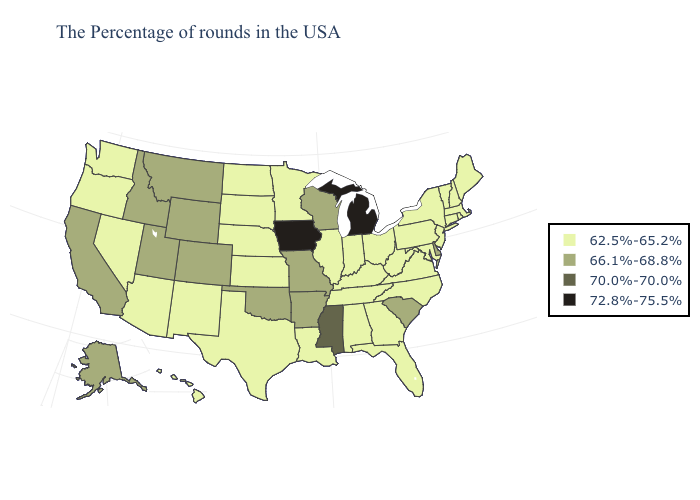Among the states that border Pennsylvania , which have the highest value?
Give a very brief answer. Delaware. Name the states that have a value in the range 70.0%-70.0%?
Quick response, please. Mississippi. Does Delaware have the highest value in the South?
Write a very short answer. No. Does the map have missing data?
Be succinct. No. Name the states that have a value in the range 72.8%-75.5%?
Keep it brief. Michigan, Iowa. What is the value of New Hampshire?
Give a very brief answer. 62.5%-65.2%. What is the highest value in the Northeast ?
Write a very short answer. 62.5%-65.2%. What is the value of New Jersey?
Give a very brief answer. 62.5%-65.2%. What is the lowest value in the USA?
Give a very brief answer. 62.5%-65.2%. Name the states that have a value in the range 72.8%-75.5%?
Short answer required. Michigan, Iowa. Does the first symbol in the legend represent the smallest category?
Write a very short answer. Yes. Name the states that have a value in the range 72.8%-75.5%?
Concise answer only. Michigan, Iowa. What is the value of Texas?
Quick response, please. 62.5%-65.2%. Is the legend a continuous bar?
Keep it brief. No. 